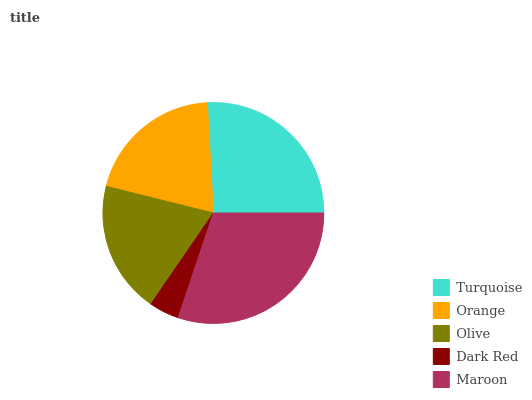Is Dark Red the minimum?
Answer yes or no. Yes. Is Maroon the maximum?
Answer yes or no. Yes. Is Orange the minimum?
Answer yes or no. No. Is Orange the maximum?
Answer yes or no. No. Is Turquoise greater than Orange?
Answer yes or no. Yes. Is Orange less than Turquoise?
Answer yes or no. Yes. Is Orange greater than Turquoise?
Answer yes or no. No. Is Turquoise less than Orange?
Answer yes or no. No. Is Orange the high median?
Answer yes or no. Yes. Is Orange the low median?
Answer yes or no. Yes. Is Dark Red the high median?
Answer yes or no. No. Is Olive the low median?
Answer yes or no. No. 